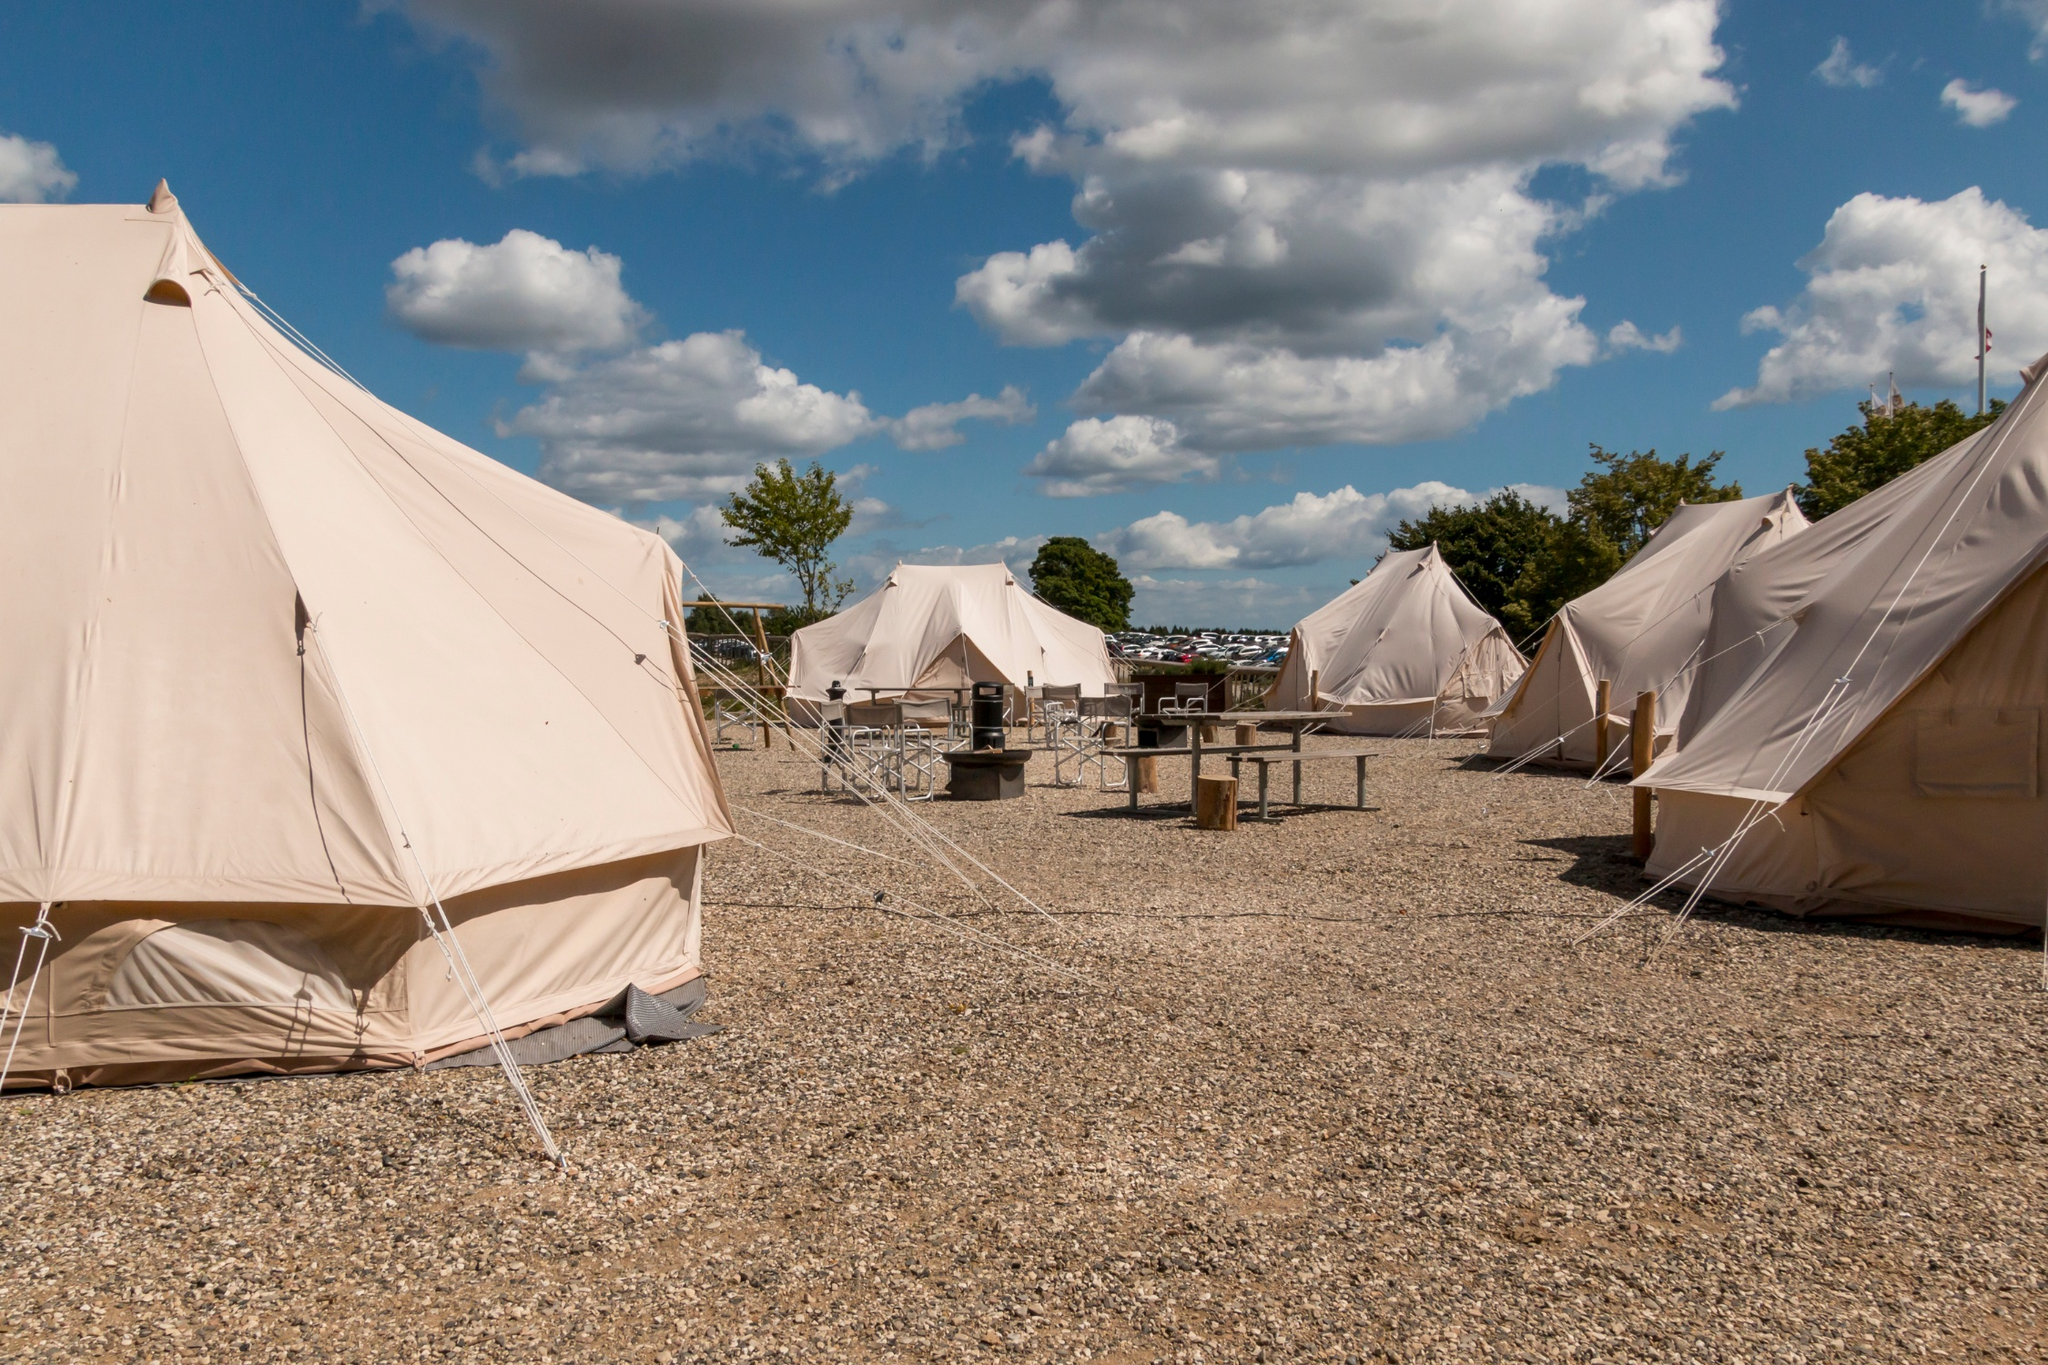Imagine you are at this campsite. What unique story would you weave around it? As twilight descended and shadows lengthened, the campers gathered around the central fire pit, its flames flickering warmly under the soft hues of the setting sun. Among them sat an elderly man, his silver hair shimmering in the firelight, known among them as the keeper of tales. Legend had it he held secret knowledge of an enchanted forest hidden beyond the trees, a place where mythical creatures roamed and ancient spirits whispered on the winds. Tonight, he decided to share one such tale. 

He began, his voice carrying a mix of mystery and nostalgia, "A long, long time ago, just beyond this campsite, there existed a hidden glade known only to the forest's oldest inhabitants. It was a place of immense beauty, where unicorns wandered freely, and fairies granted wishes to true-hearted souls. One evening, much like this, a group of campers stumbled upon this magical glade..." 

As he spoke, the campers' imaginations ran wild, envisioning themselves embarking on a midnight adventure to uncover the secrets of the enchanted forest, each wishing for their heart's deepest desire. The night grew older, yet the magic of the story lingered, weaving dreams filled with wonder and enchantment in the minds of all who listened. Can you envision this campsite transforming through the different seasons? Absolutely! In the spring, the campsite would be surrounded by blossoming flowers, with trees sprouting fresh green leaves. The air would be filled with the scent of blooming flowers and the sound of birds chirping joyfully, creating a lively, picturesque atmosphere. The tents and clear sky would reflect the renewal of life, inviting campers to enjoy the fresh, invigorating air. 

During summer, the campsite would be bathed in golden sunshine, with the trees providing pleasant shade. The atmosphere would be vibrant and warm, perfect for outdoor activities like swimming in nearby lakes, playing sports, or simply lounging in the sun on a comfortable blanket outside the tents. 

As autumn arrives, the leaves would turn shades of red, orange, and yellow, carpeting the ground around the campsite. The air would become crisper, and the scent of fallen leaves and the earthy smell of the forest would dominate. It’s the perfect time for cozying up at the campfire, with mugs of hot chocolate and the peaceful ambiance of rustling leaves. 

In winter, the campsite would be blanketed in soft snow, transforming it into a serene, white wonderland. Frost would glimmer on the tents, and the trees would be dusted with snow. Despite the cold, the clear blue sky might remain, creating a peaceful and magical scene. Campers would likely stay warm inside their tents or gather around a roaring fire, wrapped in thick blankets, making the most of the stunning, tranquil winter landscape. What could be a dream-like, out-of-this-world experience at this campsite? Imagine, if you will, as night falls and the sky becomes a deep indigo canvas speckled with stars, an otherworldly phenomenon begins to unfold. The air shimmers with an ethereal glow, and the very ground seems to hum with energy. Suddenly, the campsite transforms into an interstellar gateway, with beams of luminescent lights cascading from the sky. 

A celestial ship descends, its surface reflecting the stardust around it, and beings of light emerge, inviting the campers on a cosmic journey. They explore distant galaxies, soaring through nebulae of radiant colors, witnessing the birth of stars, and making contact with benevolent extraterrestrial civilizations. Each tent, now a portal, offers glimpses into different corners of the universe, allowing campers to experience myriad wonders beyond their wildest imaginations.

Upon returning, the campers find themselves back at the campsite, the experience etched into their memories as the ship ascends and the ethereal glow fades, leaving behind a profound sense of wonder and the unshakeable belief that they had touched the stars. 